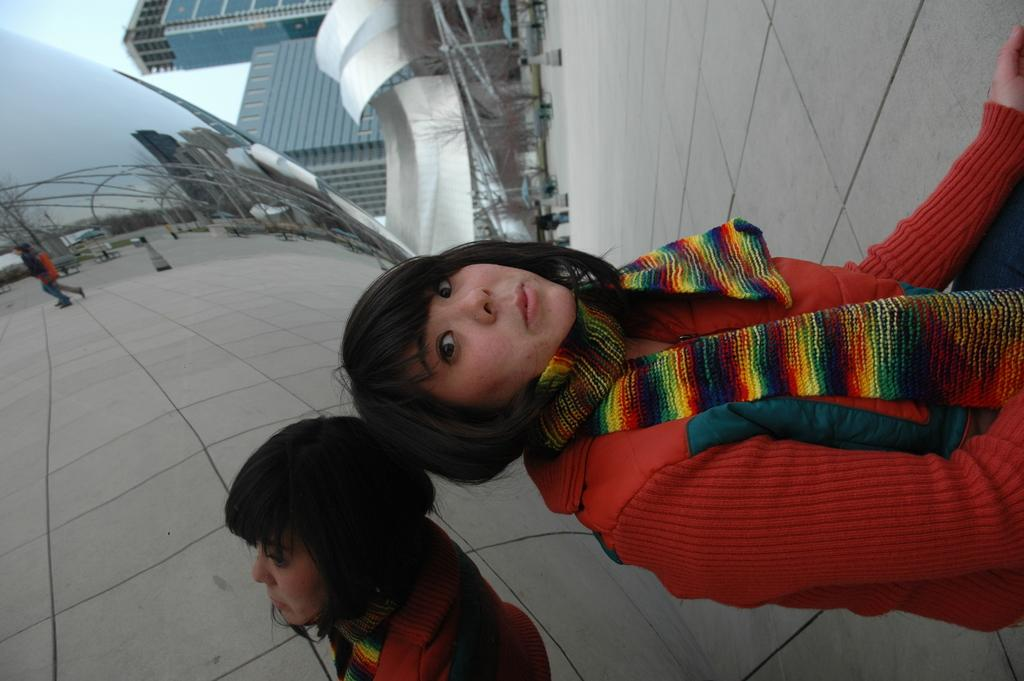What is the woman in the image doing? The woman is sitting in the image. What can be seen in the background of the image? Buildings and the sky are visible in the background of the image. What type of rail can be seen in the image? There is no rail present in the image. What time of day is it in the image, considering it's an afternoon? The time of day cannot be determined from the image, as there is no indication of the time. 